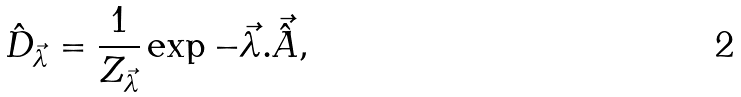<formula> <loc_0><loc_0><loc_500><loc_500>\hat { D } _ { \vec { \lambda } } = \frac { 1 } { Z _ { \vec { \lambda } } } \exp - \vec { \lambda } . \vec { \hat { A } } ,</formula> 